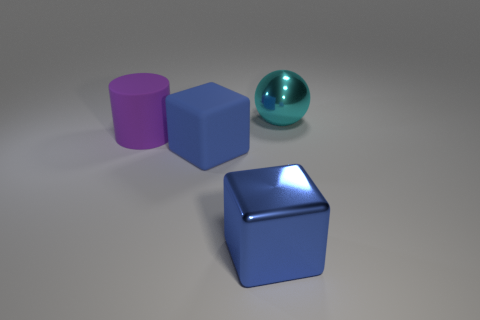Add 3 brown cylinders. How many objects exist? 7 Subtract all cylinders. How many objects are left? 3 Subtract 0 green cylinders. How many objects are left? 4 Subtract all large brown matte things. Subtract all blue objects. How many objects are left? 2 Add 4 cylinders. How many cylinders are left? 5 Add 2 cylinders. How many cylinders exist? 3 